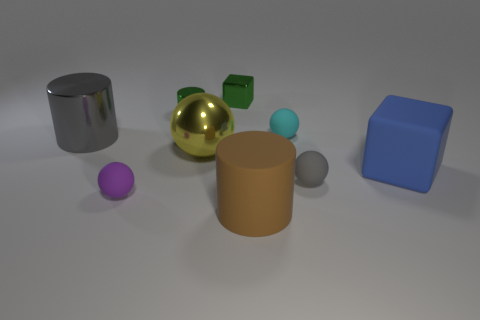What materials appear to be represented by the objects in this image? The objects in the image seem to represent a range of materials. The shiny sphere and cylinder give the impression of reflective metals, possibly simulating gold and silver. The cube and the larger cylinder have matte surfaces, hinting at a plastic or painted wood texture. 